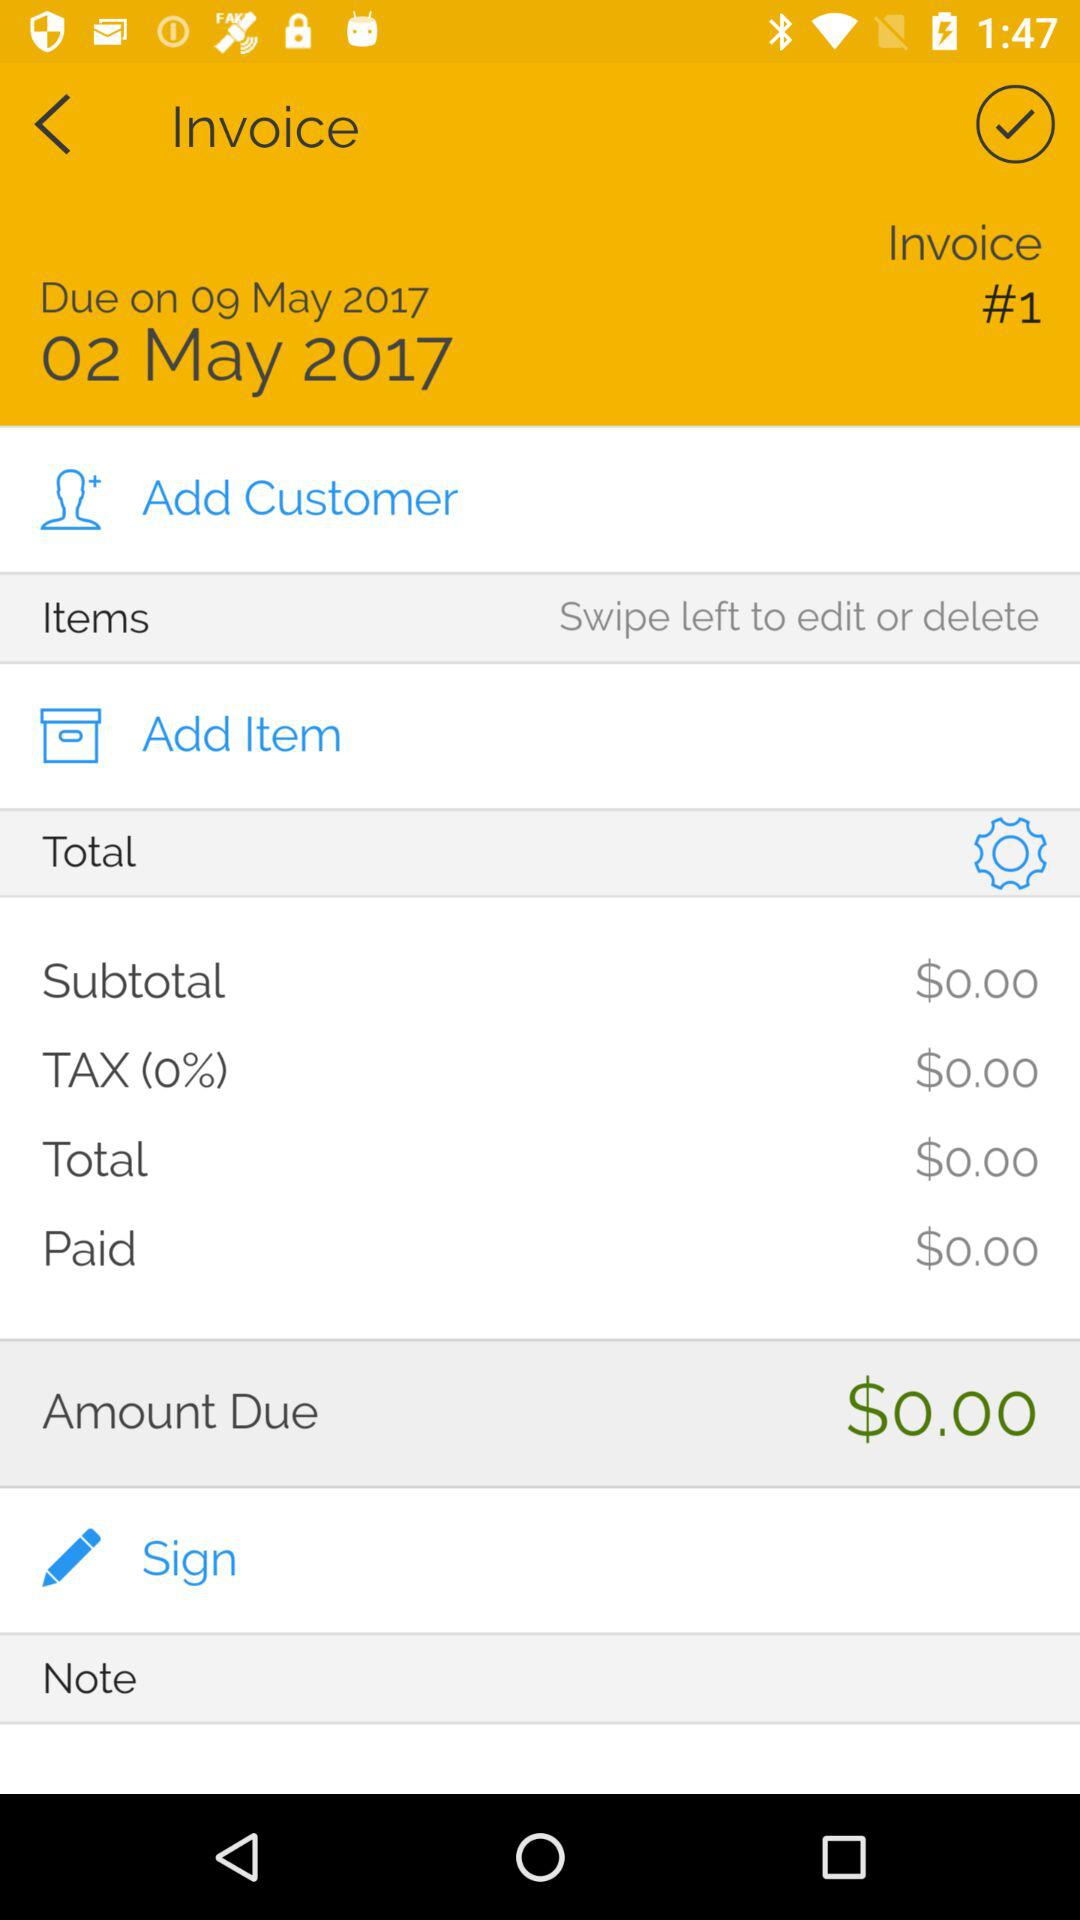What's the total amount due? The total amount due is $0.00. 